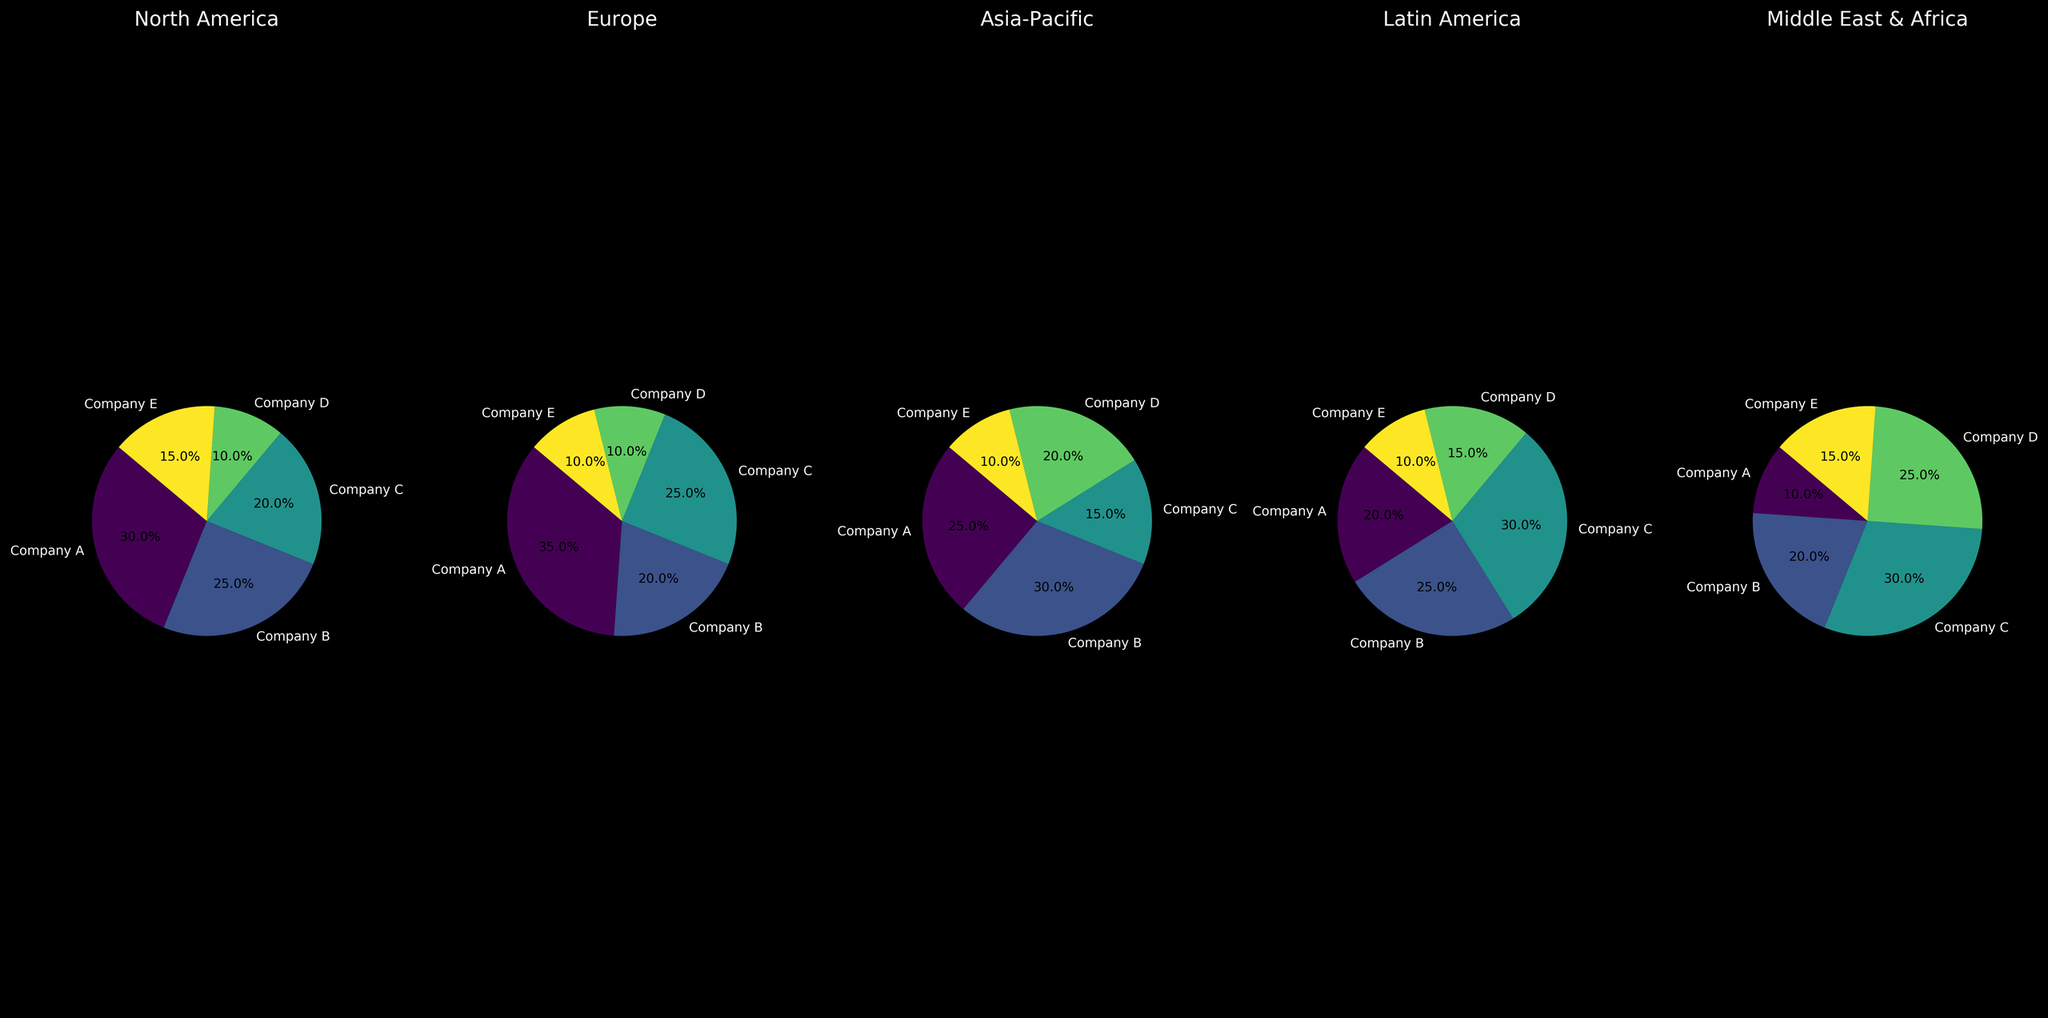Which region does Company A have the highest market share? To find which region Company A has the highest market share, look at the slices representing Company A across each region's pie chart. Compare the percentages: North America 30%, Europe 35%, Asia-Pacific 25%, Latin America 20%, and Middle East & Africa 10%. The highest value is in Europe.
Answer: Europe What is the combined market share of Company C in North America and Asia-Pacific? First, identify Company C's market share in North America, which is 20%, and in Asia-Pacific, which is 15%. Then, sum these values: 20% + 15% = 35%.
Answer: 35% Which region has the smallest combined market share for Companies D and E? Identify the combined percentages for Companies D and E in each region:
North America: 10% (D) + 15% (E) = 25%
Europe: 10% (D) + 10% (E) = 20%
Asia-Pacific: 20% (D) + 10% (E) = 30%
Latin America: 15% (D) + 10% (E) = 25%
Middle East & Africa: 25% (D) + 15% (E) = 40%
The smallest combined market share is in Europe.
Answer: Europe In which region does Company B have a larger market share than Company A? Compare Company B's market share to Company A's in each region:
North America: 25% (B) vs. 30% (A) - A has more
Europe: 20% (B) vs. 35% (A) - A has more
Asia-Pacific: 30% (B) vs. 25% (A) - B has more
Latin America: 25% (B) vs. 20% (A) - B has more
Middle East & Africa: 20% (B) vs. 10% (A) - B has more
Company B has a larger market share than Company A in Asia-Pacific, Latin America, and Middle East & Africa.
Answer: Asia-Pacific, Latin America, Middle East & Africa How does the market share of Company D in the Middle East & Africa compare to its market share in North America? Compare the slices for Company D in Middle East & Africa and North America. In the Middle East & Africa, Company D's share is 25%. In North America, it's 10%. So, Company D has a greater market share in the Middle East & Africa.
Answer: Greater in Middle East & Africa What is the average market share of Company E across all regions? To calculate the average, add Company E's market share for each region and divide by the number of regions: 
North America: 15%
Europe: 10%
Asia-Pacific: 10%
Latin America: 10%
Middle East & Africa: 15%
Sum = 15% + 10% + 10% + 10% + 15% = 60%
The number of regions is 5.
Average = 60% / 5 = 12%
Answer: 12% Which company has the largest market share in Latin America, and what is the percentage? Look at the slices for each company in the Latin America pie chart. Company C has the largest slice with 30%.
Answer: Company C with 30% Compare the combined market share of Company A and Company D in Europe with the combined share of Company B and Company C in the same region. First, find the combined market share of Company A and Company D in Europe:
Company A: 35%
Company D: 10%
Combined: 35% + 10% = 45%
Then, find the combined market share of Company B and Company C in Europe:
Company B: 20%
Company C: 25%
Combined: 20% + 25% = 45%
Both combined shares are equal.
Answer: Equal 